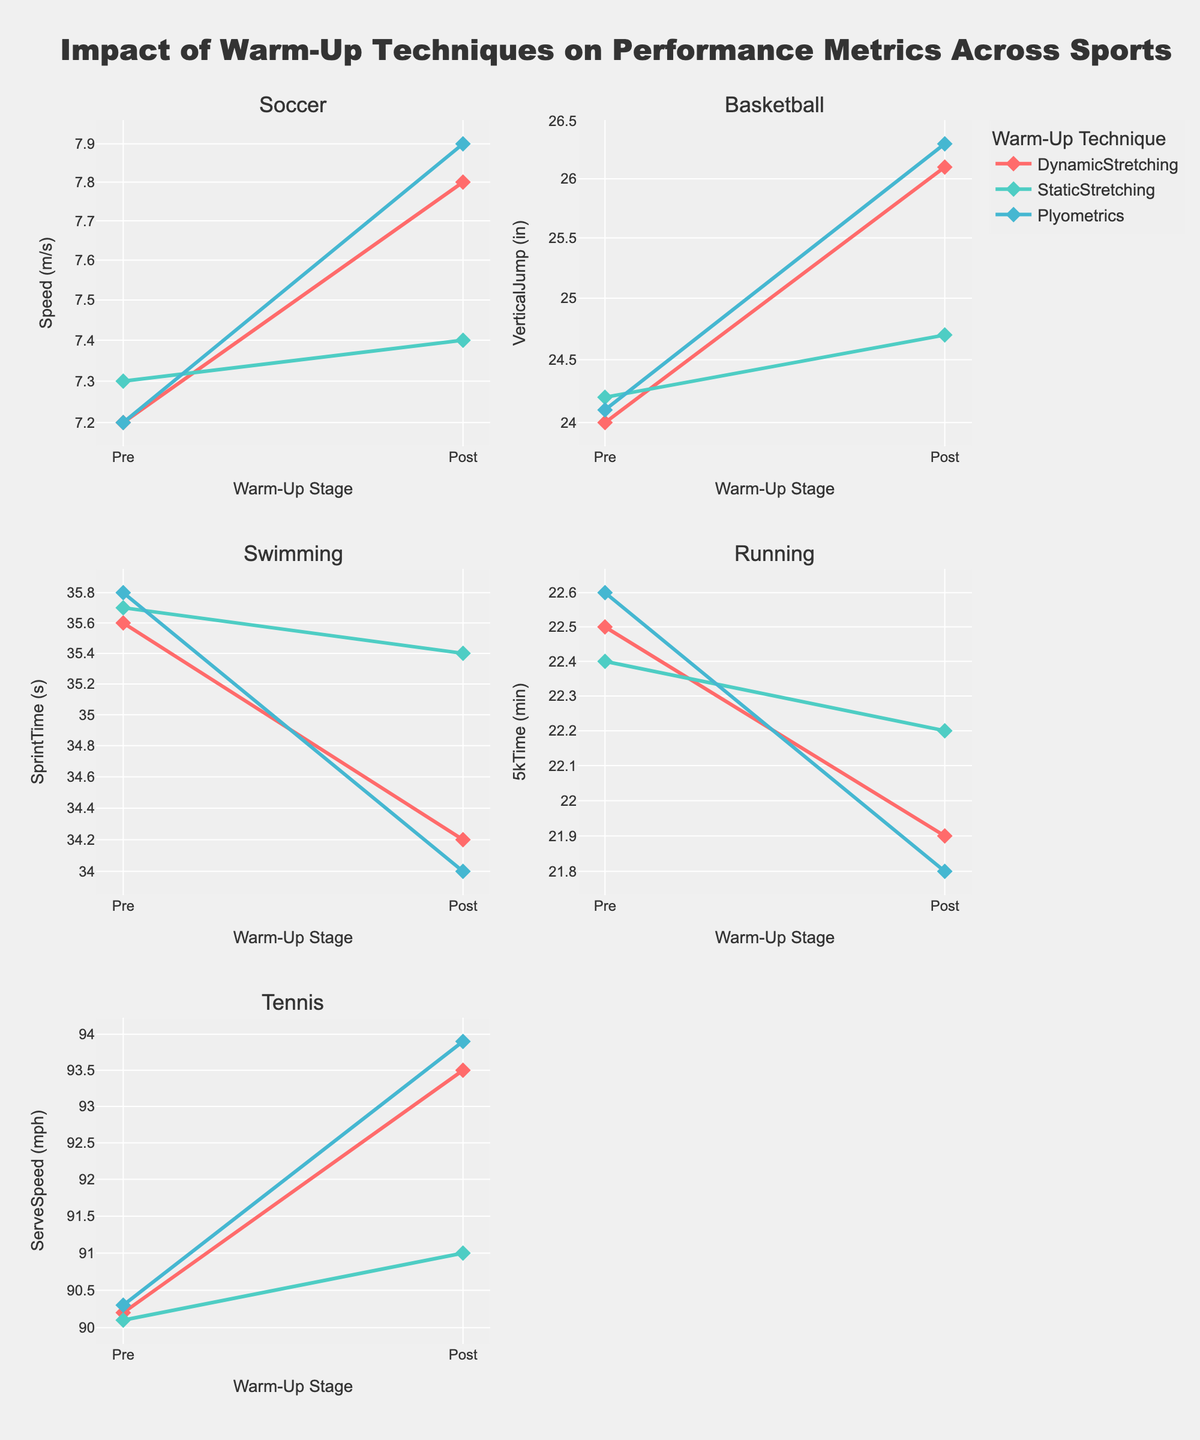How does the title describe the content of the figure? The title "Impact of Warm-Up Techniques on Performance Metrics Across Sports" suggests that the figure shows how different warm-up techniques affect performance metrics (like speed, vertical jump, sprint time, etc.) in various sports (Soccer, Basketball, Swimming, Running, Tennis) before and after warm-up.
Answer: Describes the impact of warm-up techniques on performance across different sports What kind of axis scales are used in the subplots? The y-axes in all subplots are presented with a logarithmic (log) scale, as specified by the code. This is used for visualizing different scales of performance metrics effectively.
Answer: Logarithmic scale for y-axes Which warm-up technique shows the most significant improvement in speed for Soccer? By comparing the 'Post' values in the Soccer subplot, Plyometrics shows the most significant improvement in speed, increasing from 7.2 m/s to 7.9 m/s.
Answer: Plyometrics How does Dynamic Stretching affect Vertical Jump in Basketball? The subplot for Basketball shows that Dynamic Stretching increases Vertical Jump from 24.0 inches to 26.1 inches.
Answer: Increases it from 24.0 to 26.1 inches Which sport shows the least change in performance metric after Static Stretching? By looking at the 'Post' values after Static Stretching for each sport, Running shows the least change, with the 5k Time decreasing from 22.4 minutes to 22.2 minutes.
Answer: Running Compare the impact of Plyometrics on Sprint Time for Swimming and Speed for Soccer. For Swimming, Plyometrics reduces the Sprint Time from 35.8 seconds to 34.0 seconds. For Soccer, Plyometrics increases Speed from 7.2 m/s to 7.9 m/s. Both show improvement but in different metrics and directions.
Answer: Both show improvement but in different metrics What is the primary visual indicator that conveys improvements in performance metric in this figure? The primary visual indicator is the difference between the 'Pre' and 'Post' lines/markers in each subplot. A clear upward or downward trend depending on the metric (e.g., Speed, Sprint Time, etc.) indicates improvement due to warm-up techniques.
Answer: Difference between 'Pre' and 'Post' markers How do the effects of Static Stretching on Serve Speed in Tennis and Speed in Soccer compare? Static Stretching slightly increases Serve Speed in Tennis from 90.1 mph to 91.0 mph but has a much smaller effect on Speed in Soccer, increasing from 7.3 m/s to 7.4 m/s.
Answer: Similar minor improvements What log scale transformation is used for the y-axis in the plots? The y-axis uses a logarithmic transformation to display performance metrics, which helps in visualizing large variations in the data effectively.
Answer: Logarithmic transformation 